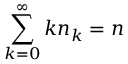<formula> <loc_0><loc_0><loc_500><loc_500>\sum _ { k = 0 } ^ { \infty } k n _ { k } = n</formula> 